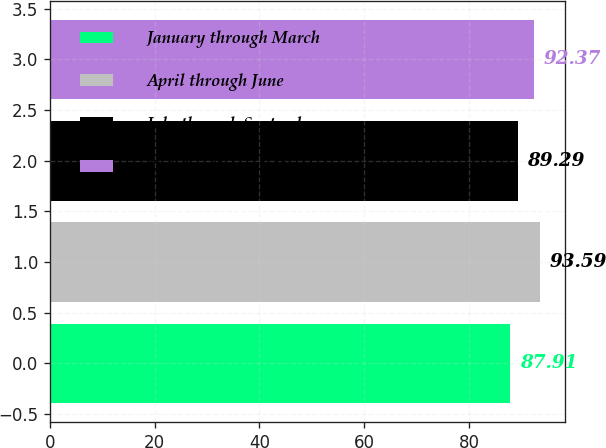<chart> <loc_0><loc_0><loc_500><loc_500><bar_chart><fcel>January through March<fcel>April through June<fcel>July through September<fcel>October through December<nl><fcel>87.91<fcel>93.59<fcel>89.29<fcel>92.37<nl></chart> 